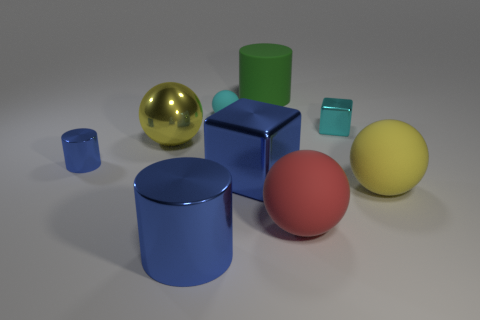There is a tiny block; are there any small cylinders on the left side of it?
Provide a short and direct response. Yes. There is a big metallic object that is the same shape as the small cyan matte object; what is its color?
Offer a very short reply. Yellow. What is the material of the big yellow ball to the right of the red ball?
Your response must be concise. Rubber. There is a cyan matte thing that is the same shape as the big yellow shiny thing; what is its size?
Provide a succinct answer. Small. What number of big cylinders have the same material as the small blue thing?
Provide a succinct answer. 1. How many small metallic cylinders have the same color as the tiny shiny block?
Offer a very short reply. 0. How many things are either matte balls behind the red matte thing or red rubber things to the right of the large blue block?
Keep it short and to the point. 3. Is the number of large shiny spheres in front of the tiny cube less than the number of rubber balls?
Give a very brief answer. Yes. Are there any rubber cylinders of the same size as the cyan metal cube?
Provide a short and direct response. No. The small cylinder is what color?
Offer a very short reply. Blue. 